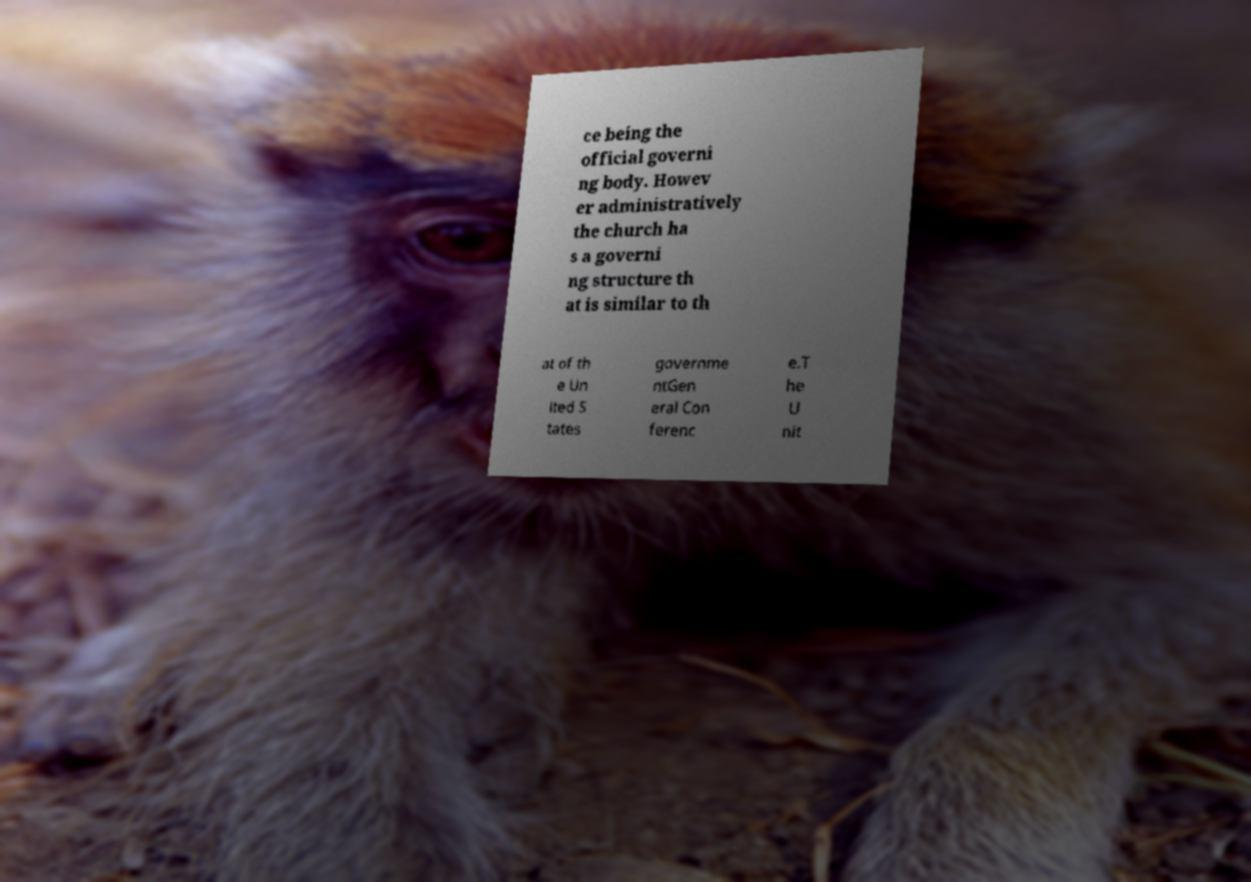Could you assist in decoding the text presented in this image and type it out clearly? ce being the official governi ng body. Howev er administratively the church ha s a governi ng structure th at is similar to th at of th e Un ited S tates governme ntGen eral Con ferenc e.T he U nit 